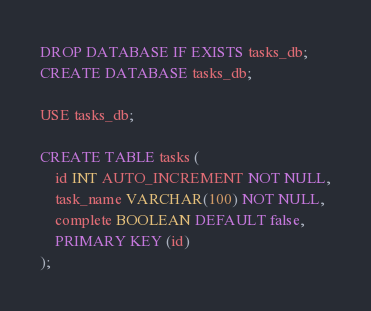<code> <loc_0><loc_0><loc_500><loc_500><_SQL_>DROP DATABASE IF EXISTS tasks_db;
CREATE DATABASE tasks_db;

USE tasks_db;

CREATE TABLE tasks (
    id INT AUTO_INCREMENT NOT NULL,
    task_name VARCHAR(100) NOT NULL,
    complete BOOLEAN DEFAULT false,
    PRIMARY KEY (id)
);</code> 